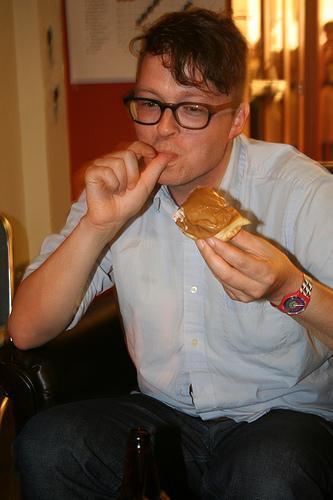How many people are in this photograph?
Give a very brief answer. 1. 